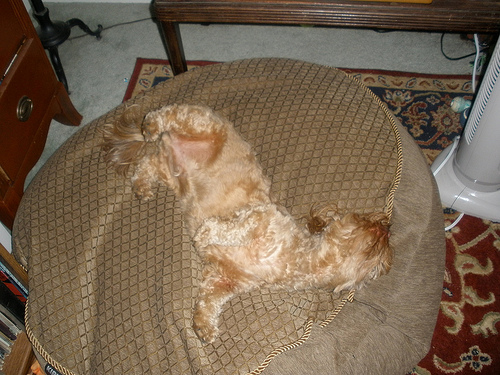<image>
Is the dog on the bed? Yes. Looking at the image, I can see the dog is positioned on top of the bed, with the bed providing support. Is the dog under the bed? No. The dog is not positioned under the bed. The vertical relationship between these objects is different. 